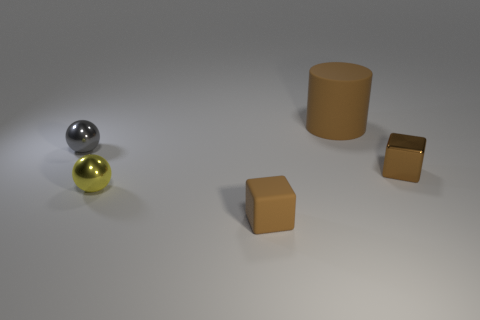The big matte thing is what shape? The large, matte object in the image is a cylinder. Its smooth texture and circular top view contrast with the other geometric figures in the scene, making it a distinct visual element. 